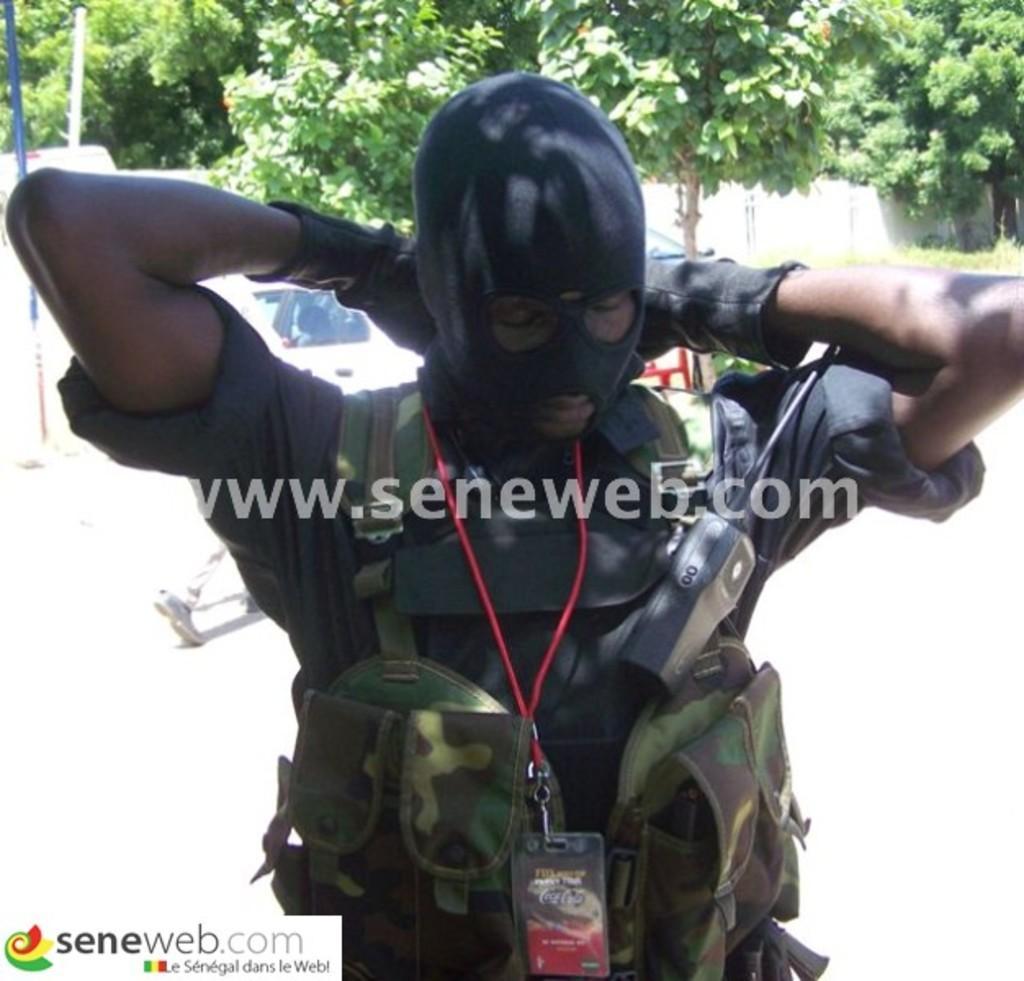Please provide a concise description of this image. This image is taken outdoors. In the background there are a few trees with green leaves. There is a wall. A car is parked on the road. On the left side of the image there are two poles. In the middle of the image a person is standing and wearing a mask on the face. At the bottom of the image there is a text. 